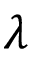<formula> <loc_0><loc_0><loc_500><loc_500>\lambda</formula> 